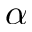<formula> <loc_0><loc_0><loc_500><loc_500>\alpha</formula> 